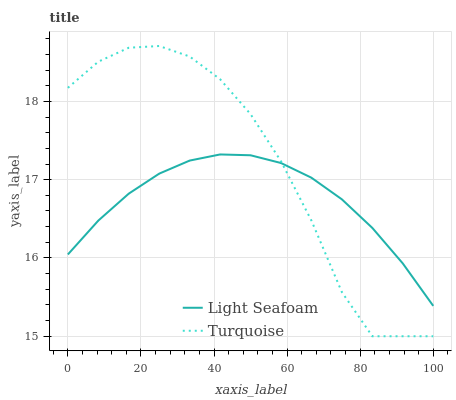Does Light Seafoam have the minimum area under the curve?
Answer yes or no. Yes. Does Turquoise have the maximum area under the curve?
Answer yes or no. Yes. Does Light Seafoam have the maximum area under the curve?
Answer yes or no. No. Is Light Seafoam the smoothest?
Answer yes or no. Yes. Is Turquoise the roughest?
Answer yes or no. Yes. Is Light Seafoam the roughest?
Answer yes or no. No. Does Turquoise have the lowest value?
Answer yes or no. Yes. Does Light Seafoam have the lowest value?
Answer yes or no. No. Does Turquoise have the highest value?
Answer yes or no. Yes. Does Light Seafoam have the highest value?
Answer yes or no. No. Does Turquoise intersect Light Seafoam?
Answer yes or no. Yes. Is Turquoise less than Light Seafoam?
Answer yes or no. No. Is Turquoise greater than Light Seafoam?
Answer yes or no. No. 